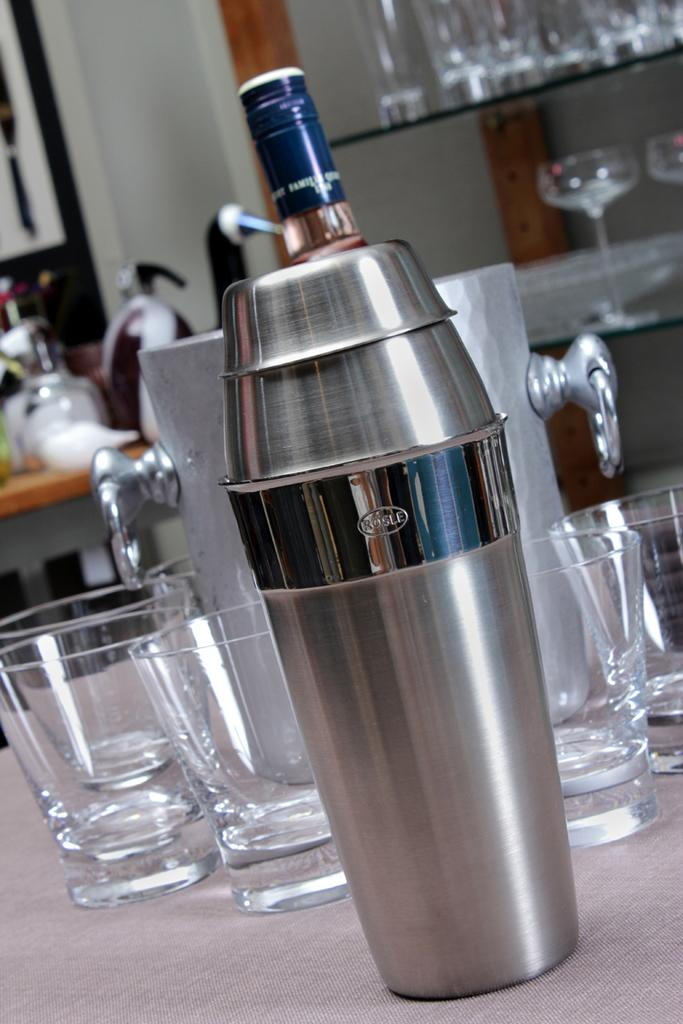<image>
Give a short and clear explanation of the subsequent image. A Rosle shaker is shown on a counter top 